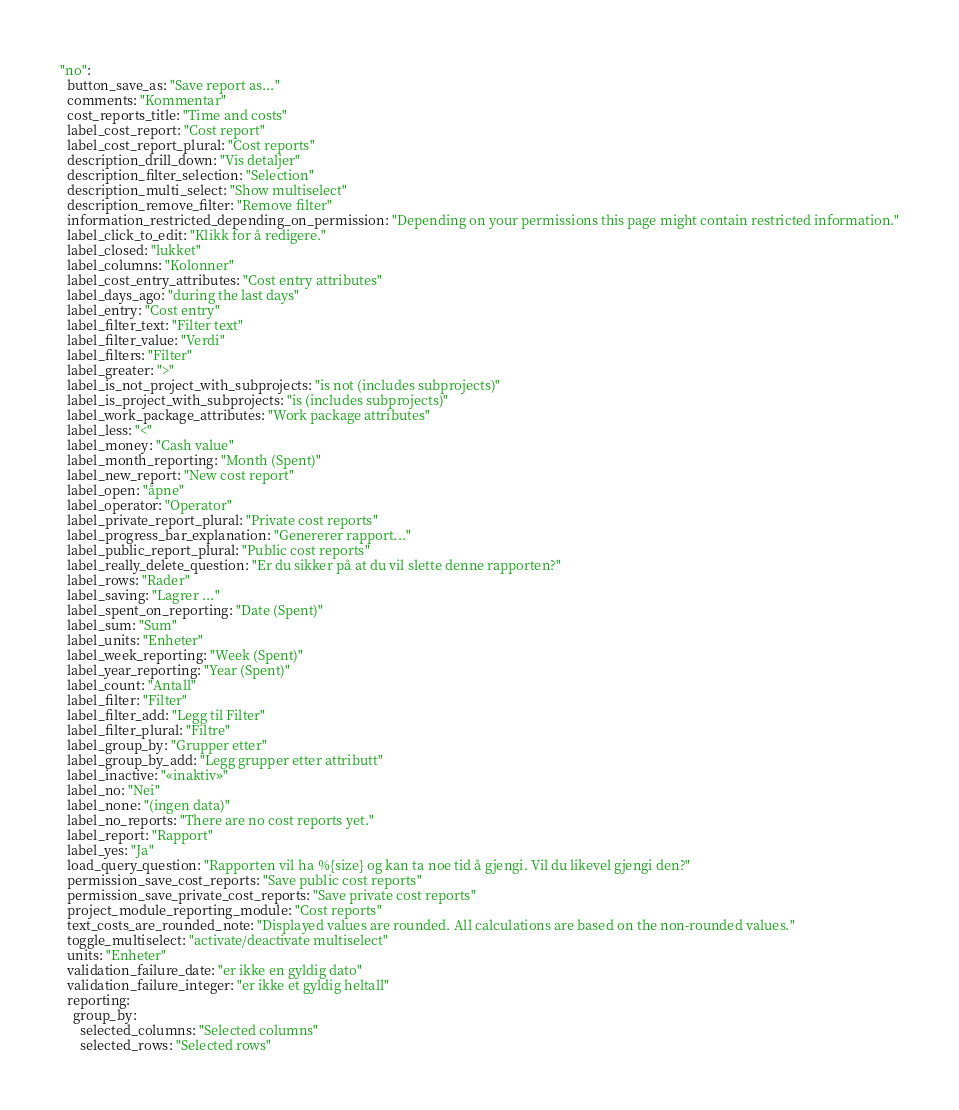Convert code to text. <code><loc_0><loc_0><loc_500><loc_500><_YAML_>"no":
  button_save_as: "Save report as..."
  comments: "Kommentar"
  cost_reports_title: "Time and costs"
  label_cost_report: "Cost report"
  label_cost_report_plural: "Cost reports"
  description_drill_down: "Vis detaljer"
  description_filter_selection: "Selection"
  description_multi_select: "Show multiselect"
  description_remove_filter: "Remove filter"
  information_restricted_depending_on_permission: "Depending on your permissions this page might contain restricted information."
  label_click_to_edit: "Klikk for å redigere."
  label_closed: "lukket"
  label_columns: "Kolonner"
  label_cost_entry_attributes: "Cost entry attributes"
  label_days_ago: "during the last days"
  label_entry: "Cost entry"
  label_filter_text: "Filter text"
  label_filter_value: "Verdi"
  label_filters: "Filter"
  label_greater: ">"
  label_is_not_project_with_subprojects: "is not (includes subprojects)"
  label_is_project_with_subprojects: "is (includes subprojects)"
  label_work_package_attributes: "Work package attributes"
  label_less: "<"
  label_money: "Cash value"
  label_month_reporting: "Month (Spent)"
  label_new_report: "New cost report"
  label_open: "åpne"
  label_operator: "Operator"
  label_private_report_plural: "Private cost reports"
  label_progress_bar_explanation: "Genererer rapport..."
  label_public_report_plural: "Public cost reports"
  label_really_delete_question: "Er du sikker på at du vil slette denne rapporten?"
  label_rows: "Rader"
  label_saving: "Lagrer ..."
  label_spent_on_reporting: "Date (Spent)"
  label_sum: "Sum"
  label_units: "Enheter"
  label_week_reporting: "Week (Spent)"
  label_year_reporting: "Year (Spent)"
  label_count: "Antall"
  label_filter: "Filter"
  label_filter_add: "Legg til Filter"
  label_filter_plural: "Filtre"
  label_group_by: "Grupper etter"
  label_group_by_add: "Legg grupper etter attributt"
  label_inactive: "«inaktiv»"
  label_no: "Nei"
  label_none: "(ingen data)"
  label_no_reports: "There are no cost reports yet."
  label_report: "Rapport"
  label_yes: "Ja"
  load_query_question: "Rapporten vil ha %{size} og kan ta noe tid å gjengi. Vil du likevel gjengi den?"
  permission_save_cost_reports: "Save public cost reports"
  permission_save_private_cost_reports: "Save private cost reports"
  project_module_reporting_module: "Cost reports"
  text_costs_are_rounded_note: "Displayed values are rounded. All calculations are based on the non-rounded values."
  toggle_multiselect: "activate/deactivate multiselect"
  units: "Enheter"
  validation_failure_date: "er ikke en gyldig dato"
  validation_failure_integer: "er ikke et gyldig heltall"
  reporting:
    group_by:
      selected_columns: "Selected columns"
      selected_rows: "Selected rows"
</code> 